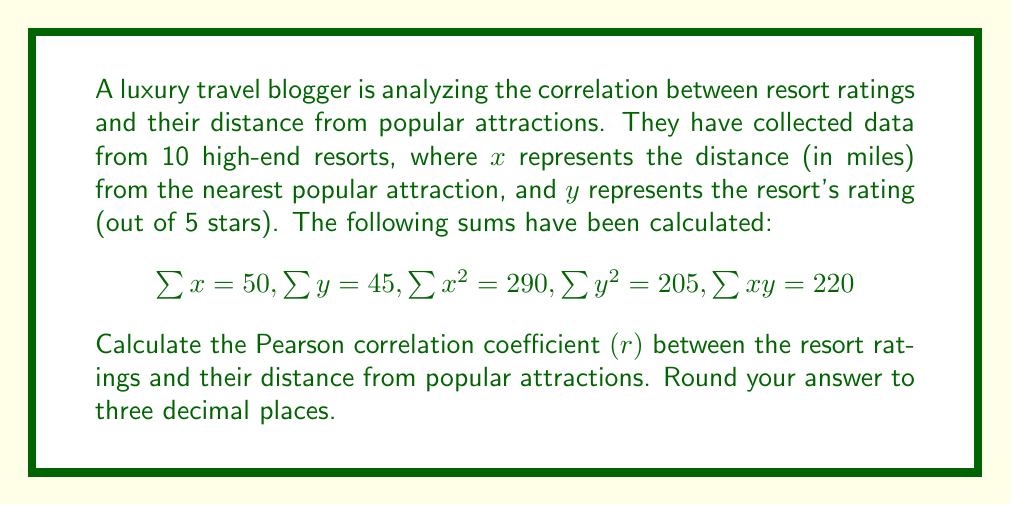Solve this math problem. To calculate the Pearson correlation coefficient $(r)$, we'll use the formula:

$$r = \frac{n\sum xy - \sum x \sum y}{\sqrt{[n\sum x^2 - (\sum x)^2][n\sum y^2 - (\sum y)^2]}}$$

Where $n$ is the number of data points (10 in this case).

Step 1: Calculate $n\sum xy$
$$n\sum xy = 10 \times 220 = 2200$$

Step 2: Calculate $\sum x \sum y$
$$\sum x \sum y = 50 \times 45 = 2250$$

Step 3: Calculate the numerator
$$2200 - 2250 = -50$$

Step 4: Calculate $n\sum x^2$ and $(\sum x)^2$
$$n\sum x^2 = 10 \times 290 = 2900$$
$$(\sum x)^2 = 50^2 = 2500$$

Step 5: Calculate $n\sum y^2$ and $(\sum y)^2$
$$n\sum y^2 = 10 \times 205 = 2050$$
$$(\sum y)^2 = 45^2 = 2025$$

Step 6: Calculate the denominator
$$\sqrt{(2900 - 2500)(2050 - 2025)} = \sqrt{400 \times 25} = \sqrt{10000} = 100$$

Step 7: Calculate $r$
$$r = \frac{-50}{100} = -0.5$$

The Pearson correlation coefficient is -0.500, rounded to three decimal places.
Answer: $-0.500$ 